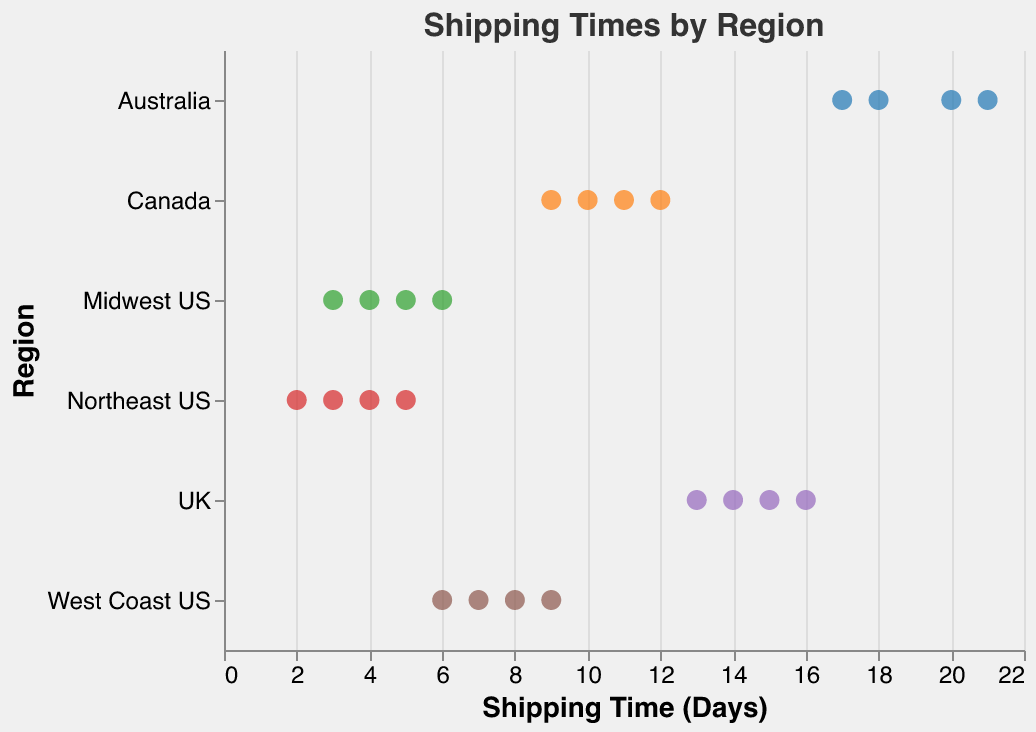How many data points are there for the Northeast US region? Count the number of points labeled as 'Northeast US' on the Y-axis. There are 4 points labeled as 'Northeast US'.
Answer: 4 What is the range of shipping times for the Midwest US? Identify the minimum and maximum shipping times for 'Midwest US' from the X-axis. The points are at 3, 4, 5, and 6 days, so the range is 3 to 6 days.
Answer: 3 to 6 days Which region has the highest shipping time? Find the maximum value on the X-axis and identify the corresponding region on the Y-axis. The highest shipping time is 21 days in the 'Australia' region.
Answer: Australia What is the average shipping time for the UK? Calculate the sum of the shipping times for 'UK' then divide by the number of points. The times are 14, 16, 13, and 15 days. (14 + 16 + 13 + 15)/4 = 58/4 = 14.5 days
Answer: 14.5 days Which region has the most consistent shipping times (smallest range)? Determine the range (difference between the max and min values) for each region and compare. The 'Northeast US' ranges from 2 to 5 days, 'Midwest US' from 3 to 6 days, 'West Coast US' from 6 to 9 days, 'Canada' from 9 to 12 days, 'UK' from 13 to 16 days, 'Australia' from 17 to 21 days. The smallest range is 3 days for 'Northeast US'.
Answer: Northeast US Are shipping times generally longer for international regions (Canada, UK, Australia) compared to the US regions? Compare the shipping times of 'Canada', 'UK', and 'Australia' with those of 'Northeast US', 'Midwest US', and 'West Coast US'. International regions exhibit higher shipping times (9-21 days) compared to US regions (2-9 days).
Answer: Yes What is the median shipping time for the West Coast US? List the shipping times for 'West Coast US': 7, 8, 6, 9. Arrange them: 6, 7, 8, 9. The median is the average of the two middle values (7 and 8). So (7 + 8) / 2 = 7.5 days.
Answer: 7.5 days 